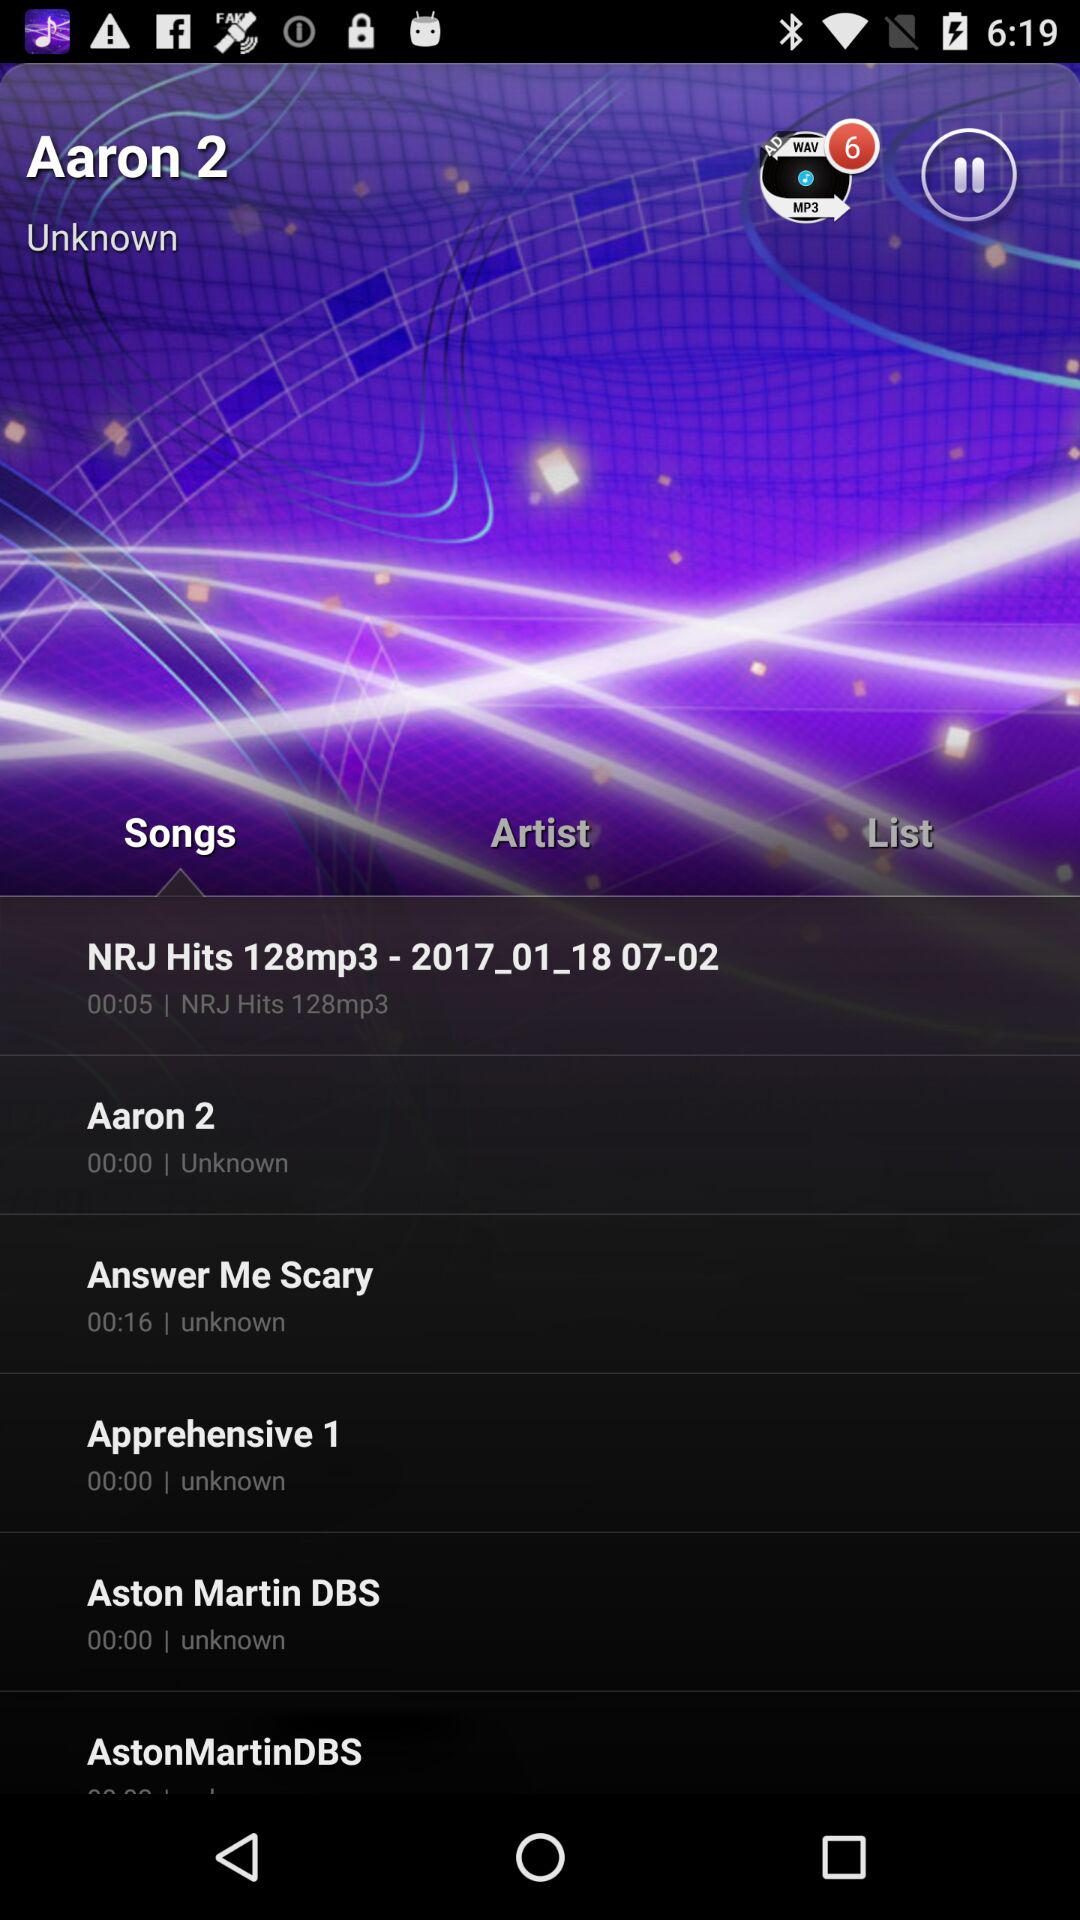What is the name of the artist of the song Aston Martin DBS? The name of the artist is unknown. 